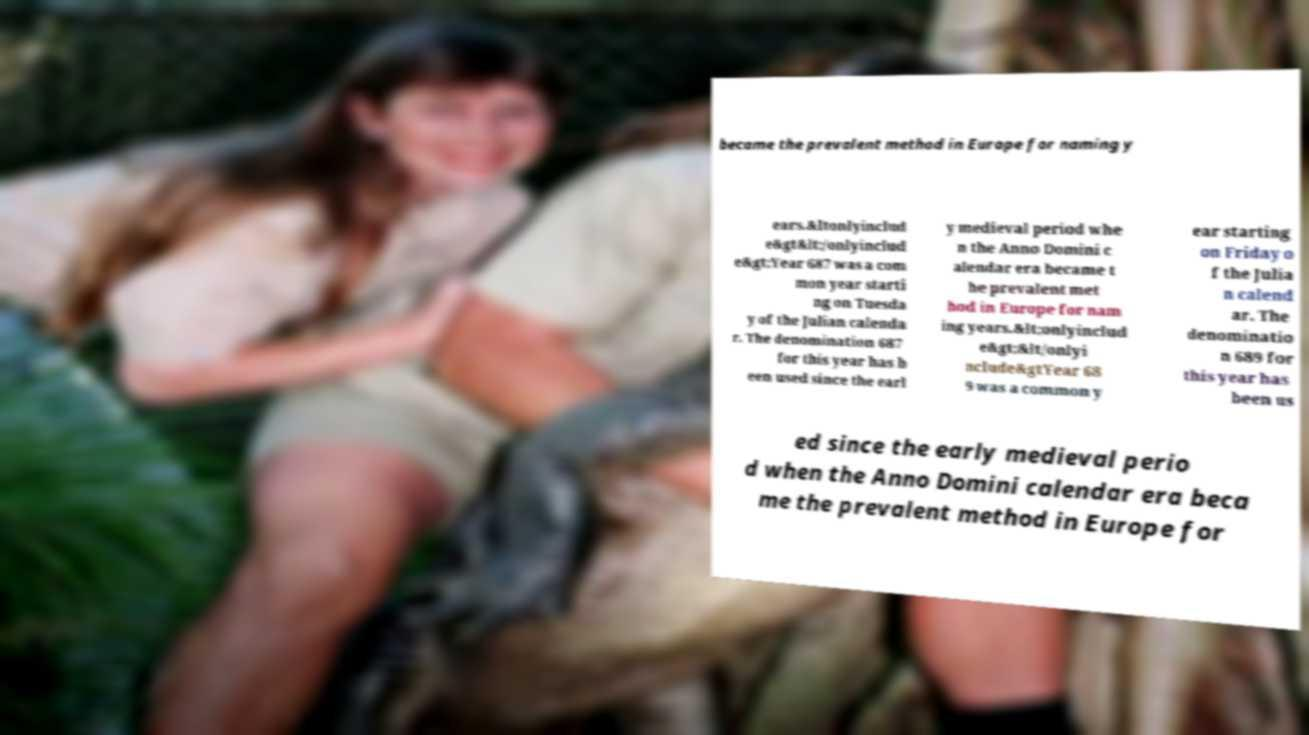Please read and relay the text visible in this image. What does it say? became the prevalent method in Europe for naming y ears.&ltonlyinclud e&gt&lt;/onlyinclud e&gt;Year 687 was a com mon year starti ng on Tuesda y of the Julian calenda r. The denomination 687 for this year has b een used since the earl y medieval period whe n the Anno Domini c alendar era became t he prevalent met hod in Europe for nam ing years.&lt;onlyinclud e&gt;&lt/onlyi nclude&gtYear 68 9 was a common y ear starting on Friday o f the Julia n calend ar. The denominatio n 689 for this year has been us ed since the early medieval perio d when the Anno Domini calendar era beca me the prevalent method in Europe for 